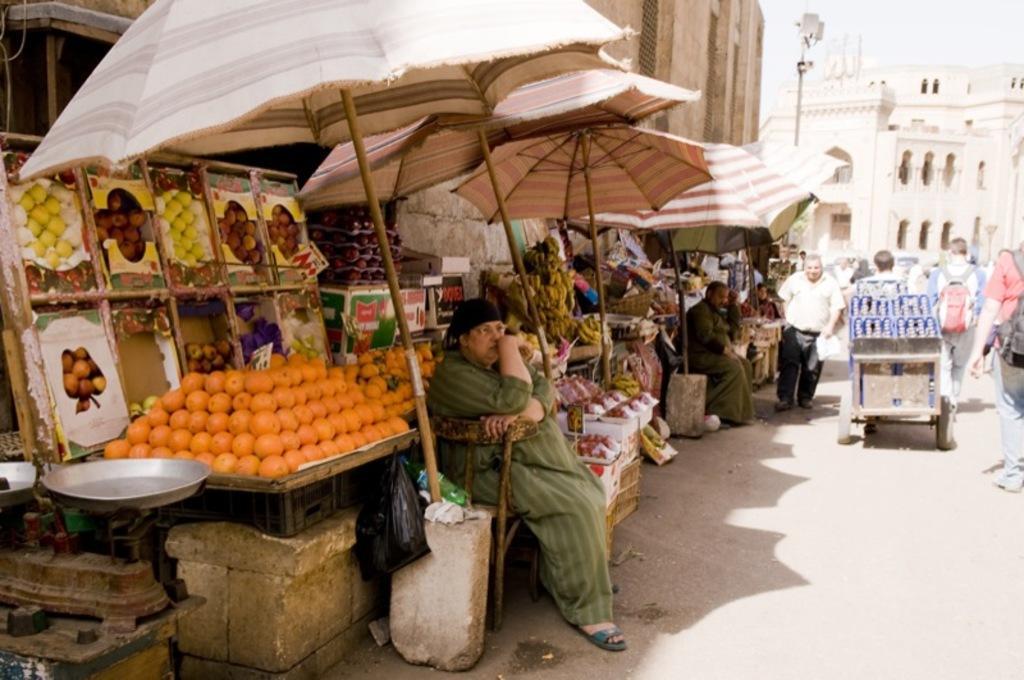Describe this image in one or two sentences. This is looking like a market. In this some people are sitting. Near to them there are umbrellas. And some fruits are there on the stands and boxes. Also there is a weighing machine on the left side. And there are brick wall. In the back there is a building. Some people are walking on the road. Also there is a cart with something on that. 